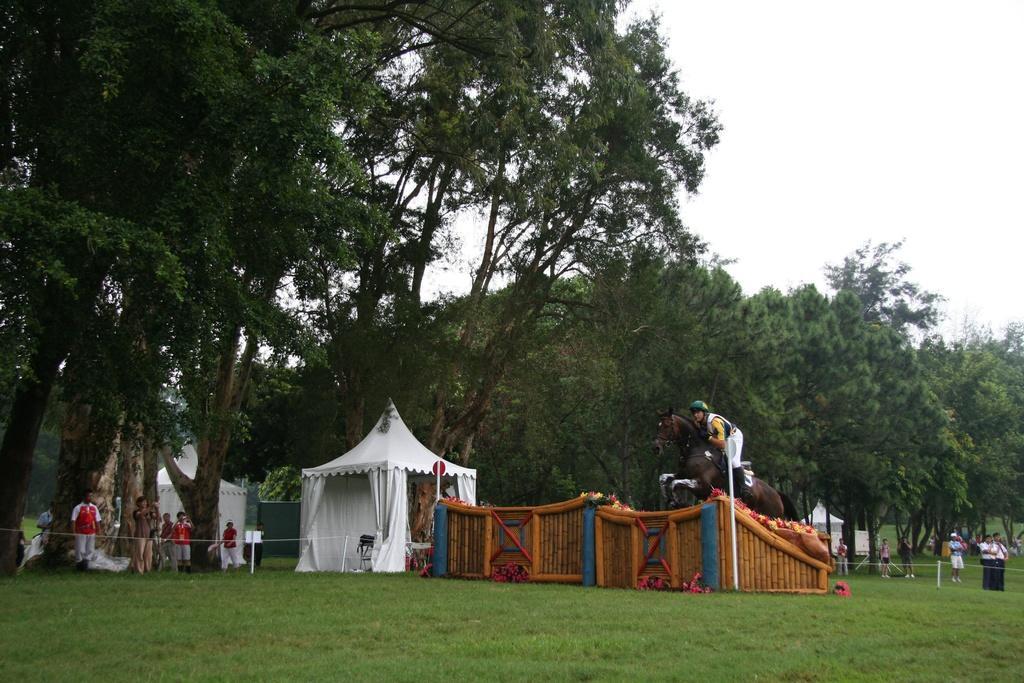In one or two sentences, can you explain what this image depicts? In the center of the image we can see tents, one wooden object, poles, sign boards and a few other objects. And we can see one person is riding a horse, few people are standing and few people are holding some objects, In the background we can see the sky, clouds, trees, grass and a few other objects. 